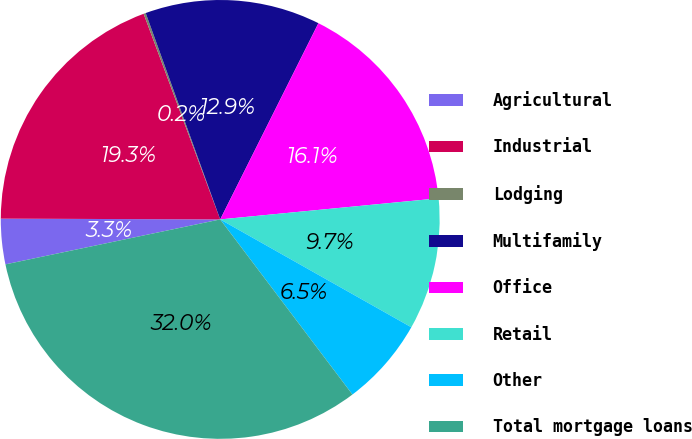Convert chart. <chart><loc_0><loc_0><loc_500><loc_500><pie_chart><fcel>Agricultural<fcel>Industrial<fcel>Lodging<fcel>Multifamily<fcel>Office<fcel>Retail<fcel>Other<fcel>Total mortgage loans<nl><fcel>3.34%<fcel>19.27%<fcel>0.16%<fcel>12.9%<fcel>16.08%<fcel>9.71%<fcel>6.53%<fcel>32.01%<nl></chart> 